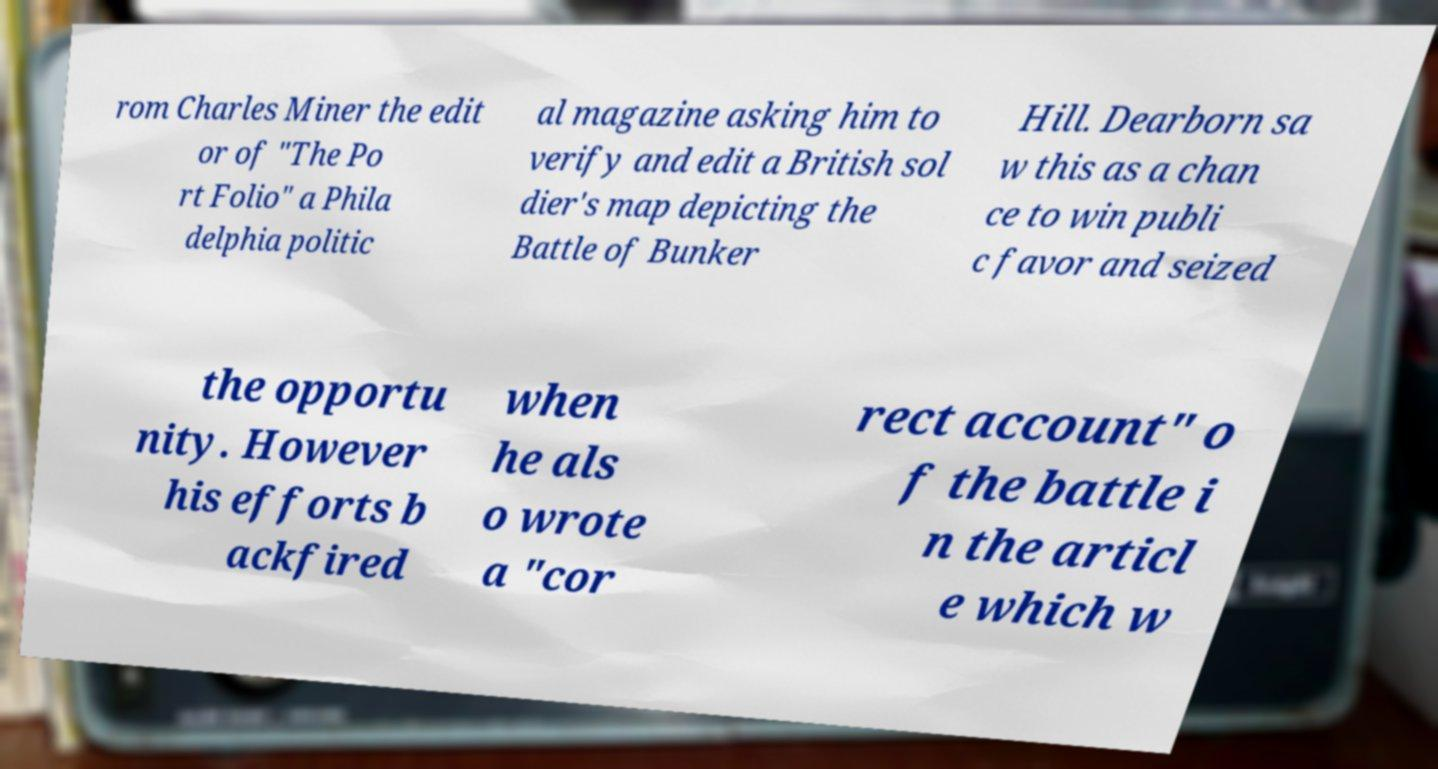Please identify and transcribe the text found in this image. rom Charles Miner the edit or of "The Po rt Folio" a Phila delphia politic al magazine asking him to verify and edit a British sol dier's map depicting the Battle of Bunker Hill. Dearborn sa w this as a chan ce to win publi c favor and seized the opportu nity. However his efforts b ackfired when he als o wrote a "cor rect account" o f the battle i n the articl e which w 